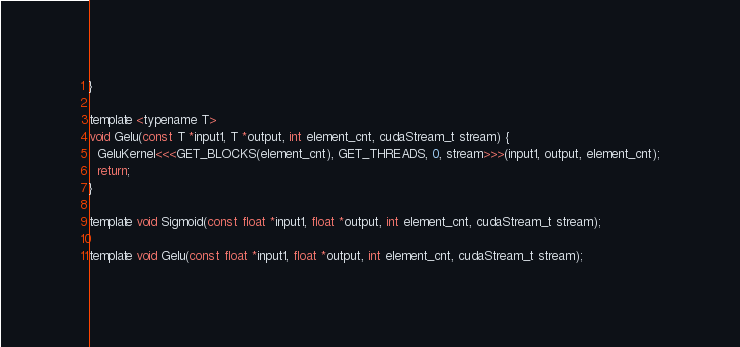Convert code to text. <code><loc_0><loc_0><loc_500><loc_500><_Cuda_>}

template <typename T>
void Gelu(const T *input1, T *output, int element_cnt, cudaStream_t stream) {
  GeluKernel<<<GET_BLOCKS(element_cnt), GET_THREADS, 0, stream>>>(input1, output, element_cnt);
  return;
}

template void Sigmoid(const float *input1, float *output, int element_cnt, cudaStream_t stream);

template void Gelu(const float *input1, float *output, int element_cnt, cudaStream_t stream);
</code> 